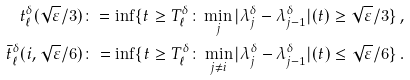<formula> <loc_0><loc_0><loc_500><loc_500>t _ { \ell } ^ { \delta } ( \sqrt { \varepsilon } / 3 ) \colon = \inf \{ t \geq T _ { \ell } ^ { \delta } \colon \min _ { j } | \lambda _ { j } ^ { \delta } - \lambda _ { j - 1 } ^ { \delta } | ( t ) \geq \sqrt { \varepsilon } / 3 \} \, , \\ \bar { t } _ { \ell } ^ { \delta } ( i , \sqrt { \varepsilon } / 6 ) \colon = \inf \{ t \geq T _ { \ell } ^ { \delta } \colon \min _ { j \neq i } | \lambda _ { j } ^ { \delta } - \lambda _ { j - 1 } ^ { \delta } | ( t ) \leq \sqrt { \varepsilon } / 6 \} \, .</formula> 